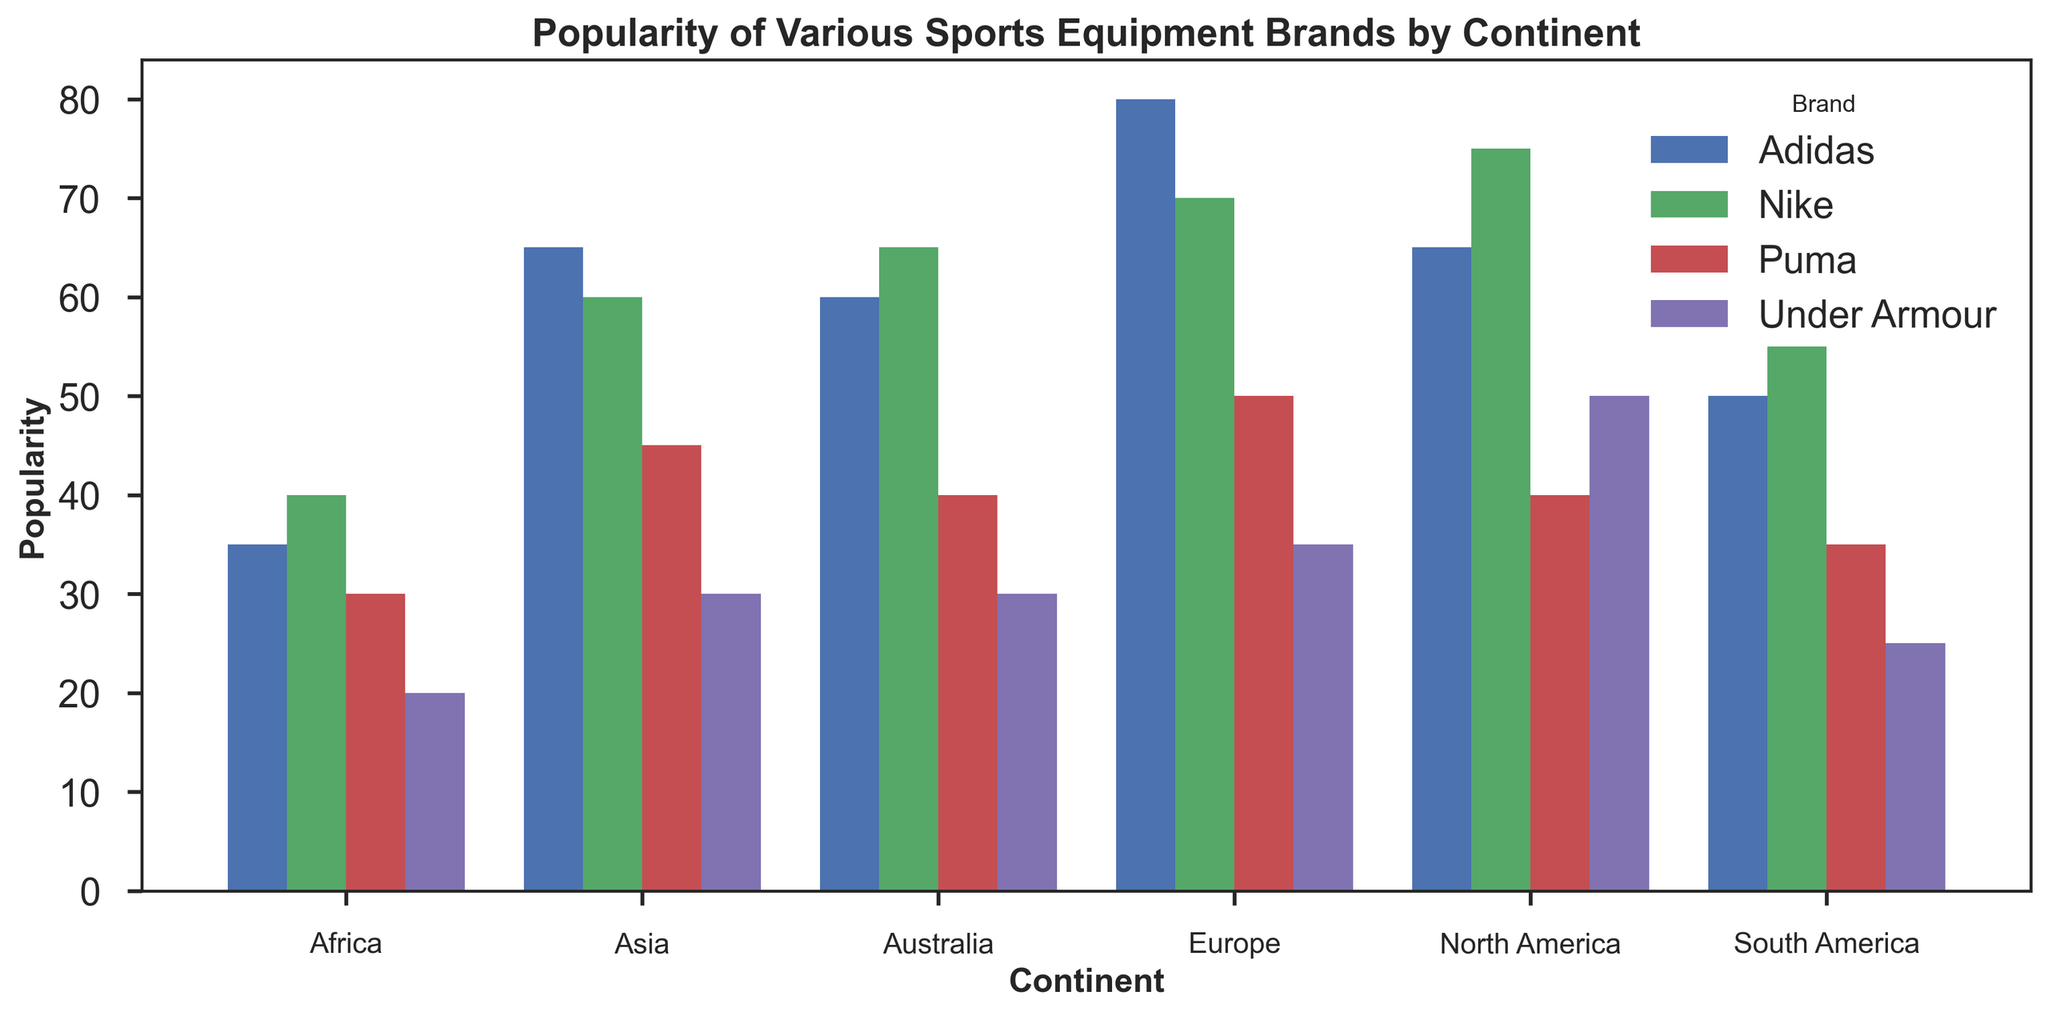Which continent shows the highest popularity for Adidas? By looking at the tallest bar for Adidas’ color in the grouped bar plot, we can see that Europe has the highest popularity, as its bar reaches up to 80.
Answer: Europe Which brand is least popular in Africa? We observe the shortest bars for the Africa section and find that Under Armour has the lowest bar reaching up to 20.
Answer: Under Armour On which continent is Puma more popular than Nike? Comparing the heights of the bars for Puma and Nike in each continent group, the plot shows that in Europe, the Puma bar (50) is lower than the Nike bar (70), so there is no continent where Puma is more popular than Nike.
Answer: None Which continent has the smallest range of popularity among the brands? The range can be found by subtracting the smallest popularity from the largest popularity for each continent:
- North America: 75 - 40 = 35
- Europe: 80 - 35 = 45
- Asia: 65 - 30 = 35
- South America: 55 - 25 = 30
- Africa: 40 - 20 = 20
- Australia: 65 - 30 = 35
Africa has the smallest range (20).
Answer: Africa What is the combined popularity of Nike in North America and Europe? Look at the heights of the Nike bars for North America and Europe; sum these values: 75 + 70 = 145
Answer: 145 Which brand has relatively even popularity across all continents? By comparing the height of bars in the same color category across all continents, Adidas has the most even heights, staying within the range of 35 - 80.
Answer: Adidas In Asia, which brand tops Under Armour by the largest margin? Checking bars for Asia, Adidas is 65, and Under Armour is 30. The difference is 35.
Nike is 60, and Under Armour is 30. The difference is 30.
Puma is 45, and Under Armour is 30. The difference is 15.
Adidas tops Under Armour by the largest margin (35).
Answer: Adidas How does the popularity of Under Armour compare between South America and Australia? Comparing the bars for Under Armour in both continents, South America’s bar is 25 and Australia's bar is 30, so Australia is higher by 5 points.
Answer: Australia is higher Which continent has the highest overall popularity when summing the popularity of all brands? Sum the heights for all brand bars for each continent:
- North America: 75 + 65 + 40 + 50 = 230
- Europe: 70 + 80 + 50 + 35 = 235
- Asia: 60 + 65 + 45 + 30 = 200
- South America: 55 + 50 + 35 + 25 = 165
- Africa: 40 + 35 + 30 + 20 = 125
- Australia: 65 + 60 + 40 + 30 = 195
Europe has the highest sum, 235.
Answer: Europe What is the average popularity of all brands in South America? Calculating the average by summing the heights of the South America bars and dividing by the number of brands: (55 + 50 + 35 + 25) / 4 = 165 / 4 = 41.25
Answer: 41.25 